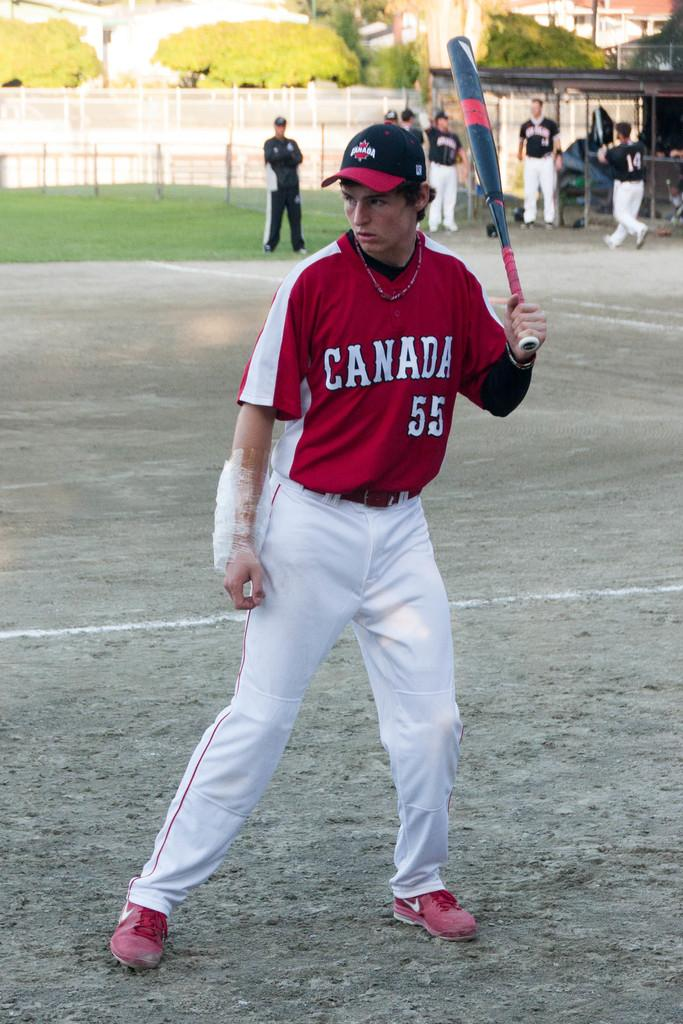Provide a one-sentence caption for the provided image. Player #55 for the Canada team gets ready to bat. 